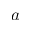Convert formula to latex. <formula><loc_0><loc_0><loc_500><loc_500>a</formula> 